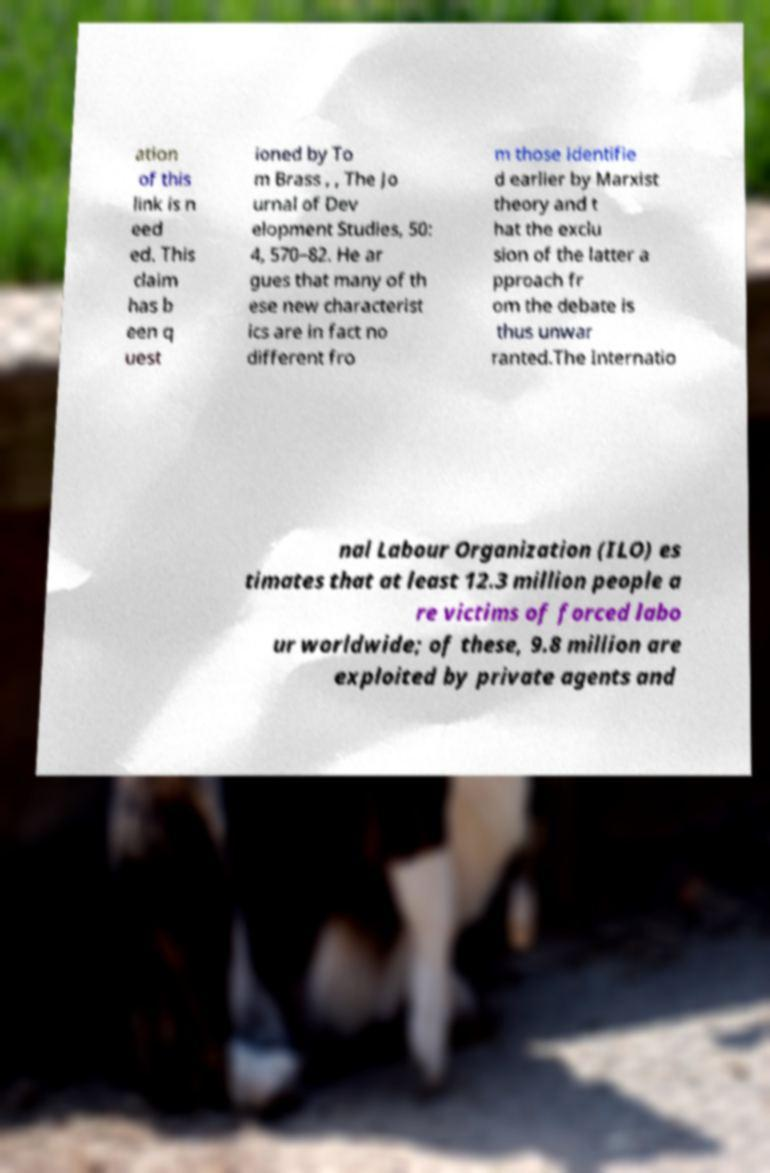Please identify and transcribe the text found in this image. ation of this link is n eed ed. This claim has b een q uest ioned by To m Brass , , The Jo urnal of Dev elopment Studies, 50: 4, 570–82. He ar gues that many of th ese new characterist ics are in fact no different fro m those identifie d earlier by Marxist theory and t hat the exclu sion of the latter a pproach fr om the debate is thus unwar ranted.The Internatio nal Labour Organization (ILO) es timates that at least 12.3 million people a re victims of forced labo ur worldwide; of these, 9.8 million are exploited by private agents and 